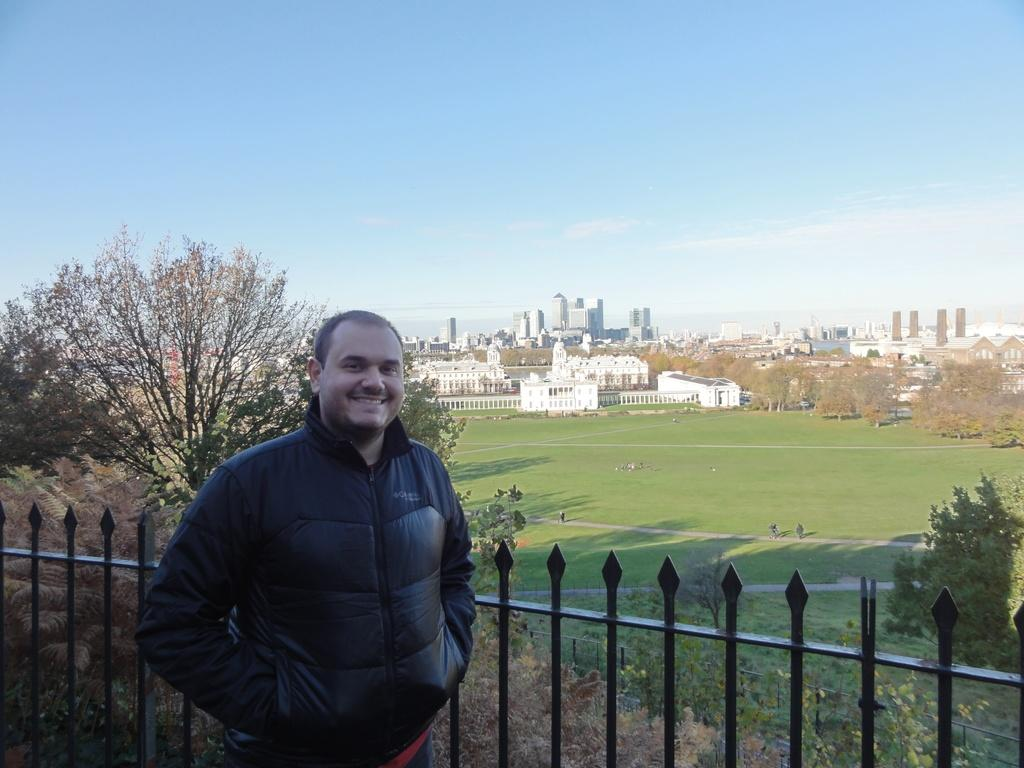Who is present in the image? There is a man in the image. What is the man doing in the image? The man is standing in front of a railing. What is the man's facial expression in the image? The man is smiling. What can be seen in the background of the image? There are buildings, trees, and the sky visible in the background of the image. What type of pump is being used to cover the man's trousers in the image? There is no pump or trousers present in the image, and therefore no such activity can be observed. 